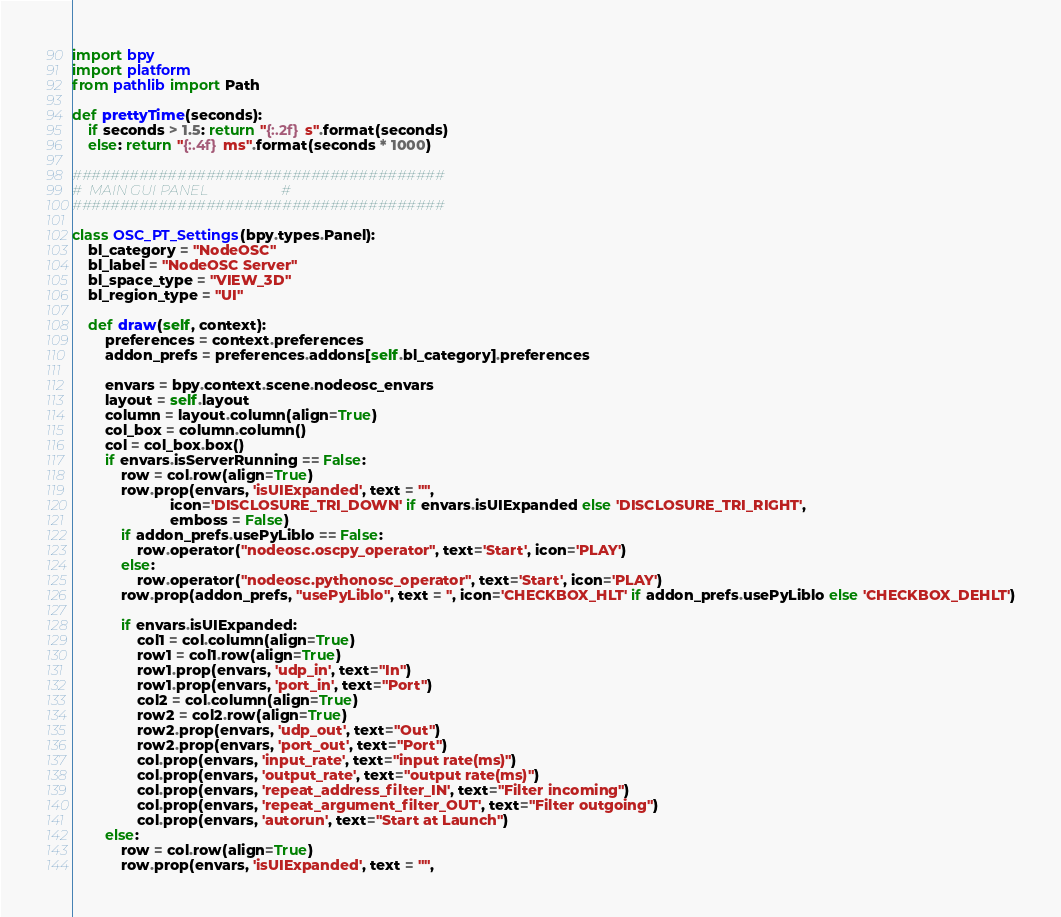Convert code to text. <code><loc_0><loc_0><loc_500><loc_500><_Python_>import bpy
import platform
from pathlib import Path

def prettyTime(seconds):
    if seconds > 1.5: return "{:.2f} s".format(seconds)
    else: return "{:.4f} ms".format(seconds * 1000)
    
#######################################
#  MAIN GUI PANEL                     #
#######################################

class OSC_PT_Settings(bpy.types.Panel):
    bl_category = "NodeOSC"
    bl_label = "NodeOSC Server"
    bl_space_type = "VIEW_3D"
    bl_region_type = "UI"

    def draw(self, context):
        preferences = context.preferences
        addon_prefs = preferences.addons[self.bl_category].preferences           
 
        envars = bpy.context.scene.nodeosc_envars
        layout = self.layout
        column = layout.column(align=True)
        col_box = column.column()
        col = col_box.box()
        if envars.isServerRunning == False:
            row = col.row(align=True)
            row.prop(envars, 'isUIExpanded', text = "", 
                        icon='DISCLOSURE_TRI_DOWN' if envars.isUIExpanded else 'DISCLOSURE_TRI_RIGHT', 
                        emboss = False)
            if addon_prefs.usePyLiblo == False:
                row.operator("nodeosc.oscpy_operator", text='Start', icon='PLAY')
            else:
                row.operator("nodeosc.pythonosc_operator", text='Start', icon='PLAY')
            row.prop(addon_prefs, "usePyLiblo", text = '', icon='CHECKBOX_HLT' if addon_prefs.usePyLiblo else 'CHECKBOX_DEHLT')

            if envars.isUIExpanded:
                col1 = col.column(align=True)
                row1 = col1.row(align=True)
                row1.prop(envars, 'udp_in', text="In")
                row1.prop(envars, 'port_in', text="Port")
                col2 = col.column(align=True)
                row2 = col2.row(align=True)
                row2.prop(envars, 'udp_out', text="Out")
                row2.prop(envars, 'port_out', text="Port")
                col.prop(envars, 'input_rate', text="input rate(ms)")
                col.prop(envars, 'output_rate', text="output rate(ms)")
                col.prop(envars, 'repeat_address_filter_IN', text="Filter incoming")
                col.prop(envars, 'repeat_argument_filter_OUT', text="Filter outgoing")
                col.prop(envars, 'autorun', text="Start at Launch")
        else:
            row = col.row(align=True)
            row.prop(envars, 'isUIExpanded', text = "", </code> 